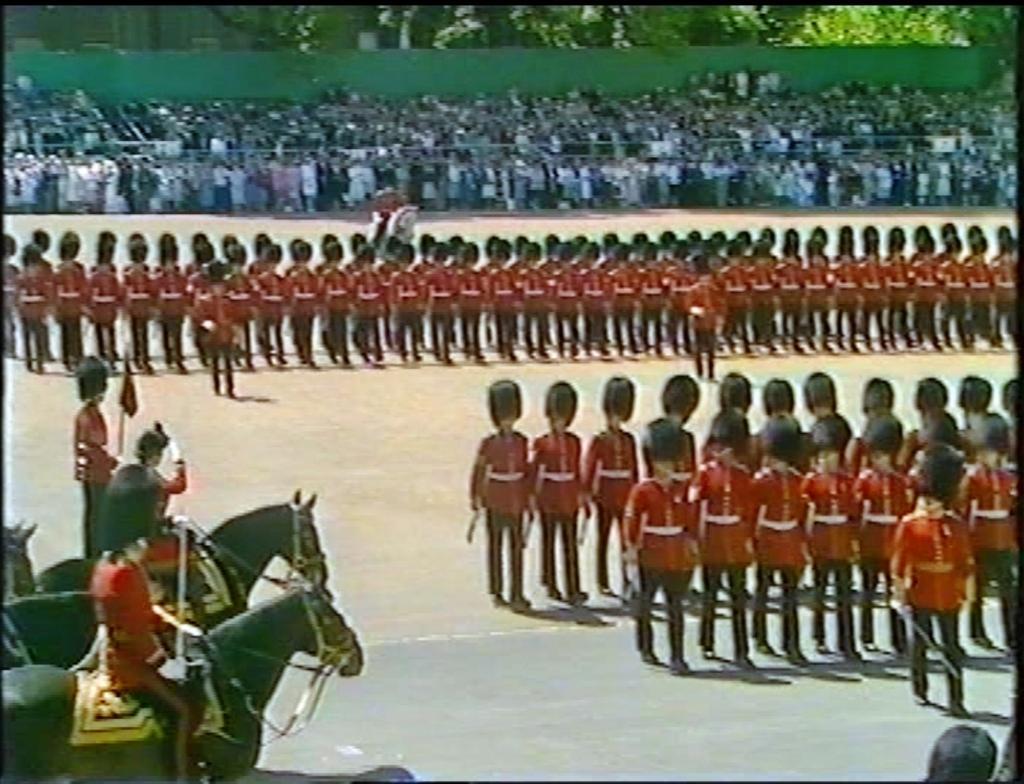Could you give a brief overview of what you see in this image? In the picture I can see few persons wearing red dress are standing and there are few persons sitting on horses in the left corner and there are few audience and trees in the left corner. 